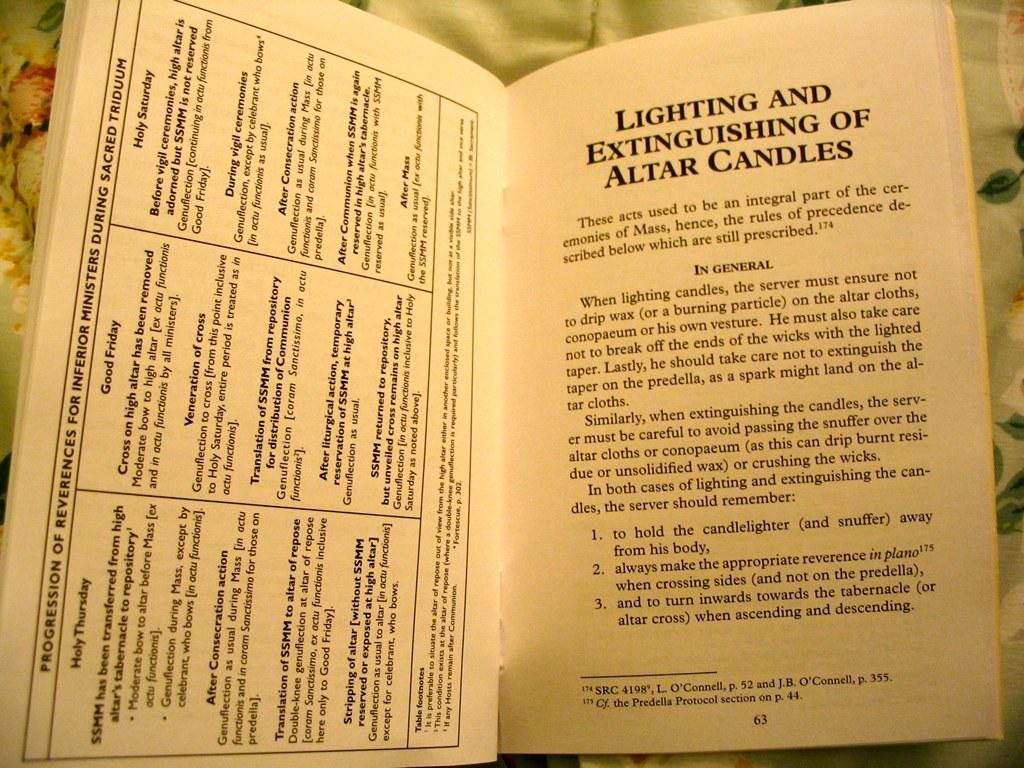<image>
Provide a brief description of the given image. Book lays open on a flower cloth reading lighting and extinguishing of altar candles 